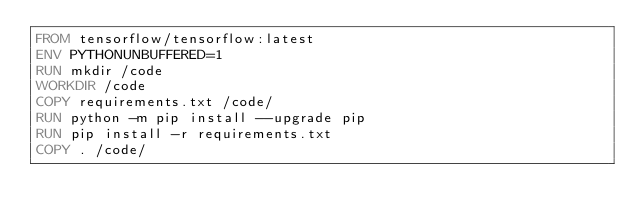<code> <loc_0><loc_0><loc_500><loc_500><_Dockerfile_>FROM tensorflow/tensorflow:latest
ENV PYTHONUNBUFFERED=1
RUN mkdir /code
WORKDIR /code
COPY requirements.txt /code/
RUN python -m pip install --upgrade pip
RUN pip install -r requirements.txt
COPY . /code/</code> 